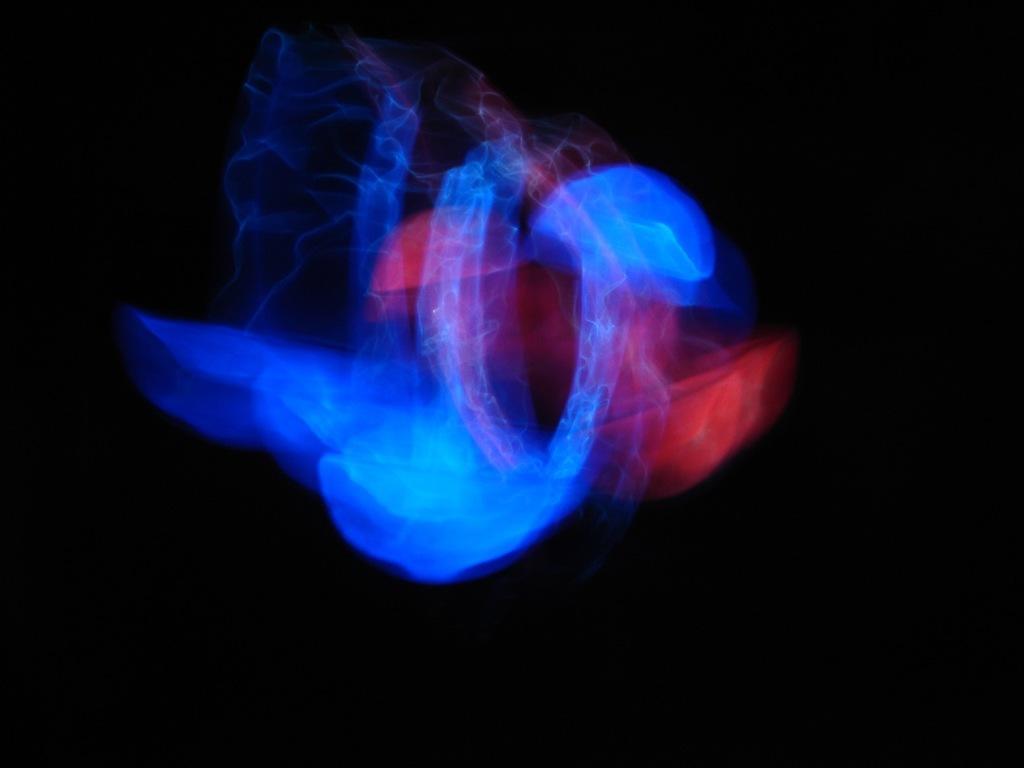Can you describe this image briefly? In the middle I can see lights. The background is dark in color. This image is taken may be during night. 